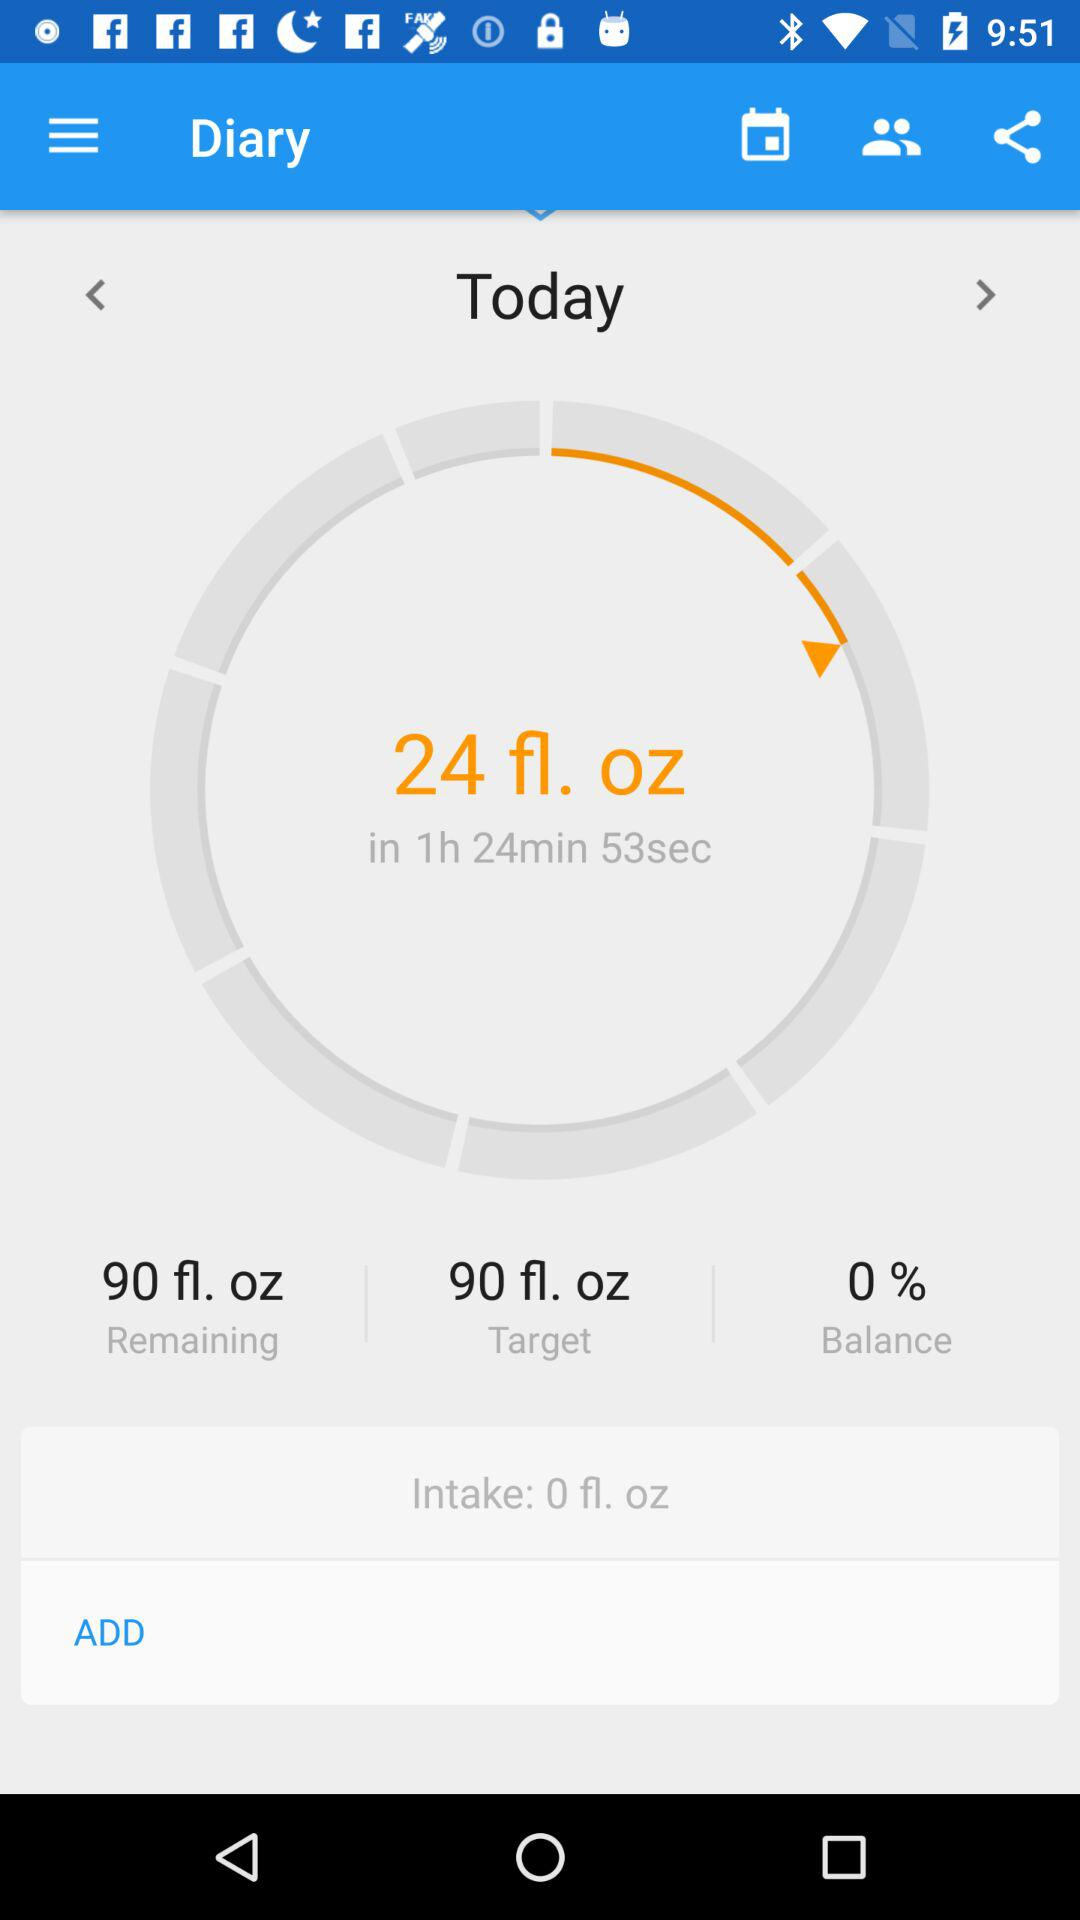How much water have I already drunk?
Answer the question using a single word or phrase. 0 fl. oz 